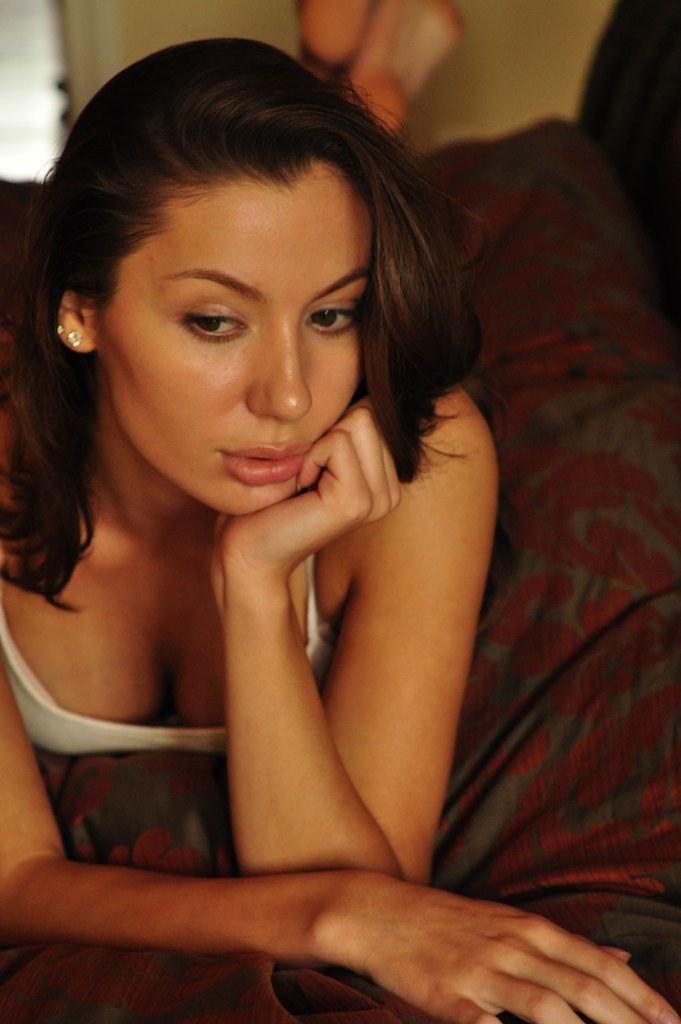Please provide a concise description of this image. In this image there is a person lying on an object. 